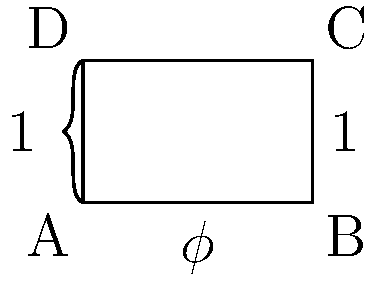In Renaissance art, the Golden Rectangle was often used for its aesthetic properties. If the shorter side of a Golden Rectangle measures 1 unit, calculate the perimeter of the rectangle. Express your answer in terms of $\phi$ (phi), the golden ratio. Let's approach this step-by-step:

1) The Golden Rectangle has a ratio of 1:$\phi$ for its sides, where $\phi$ is the golden ratio.

2) The golden ratio $\phi$ is defined as:
   $$\phi = \frac{1 + \sqrt{5}}{2} \approx 1.618033989$$

3) In our case, the shorter side is given as 1 unit. Therefore:
   - Short side = 1
   - Long side = $\phi$

4) The perimeter of a rectangle is given by the formula:
   $$P = 2l + 2w$$
   where $l$ is the length and $w$ is the width.

5) Substituting our values:
   $$P = 2(\phi) + 2(1)$$

6) Simplifying:
   $$P = 2\phi + 2$$

Therefore, the perimeter of the Golden Rectangle with a short side of 1 unit is $2\phi + 2$ units.
Answer: $2\phi + 2$ 